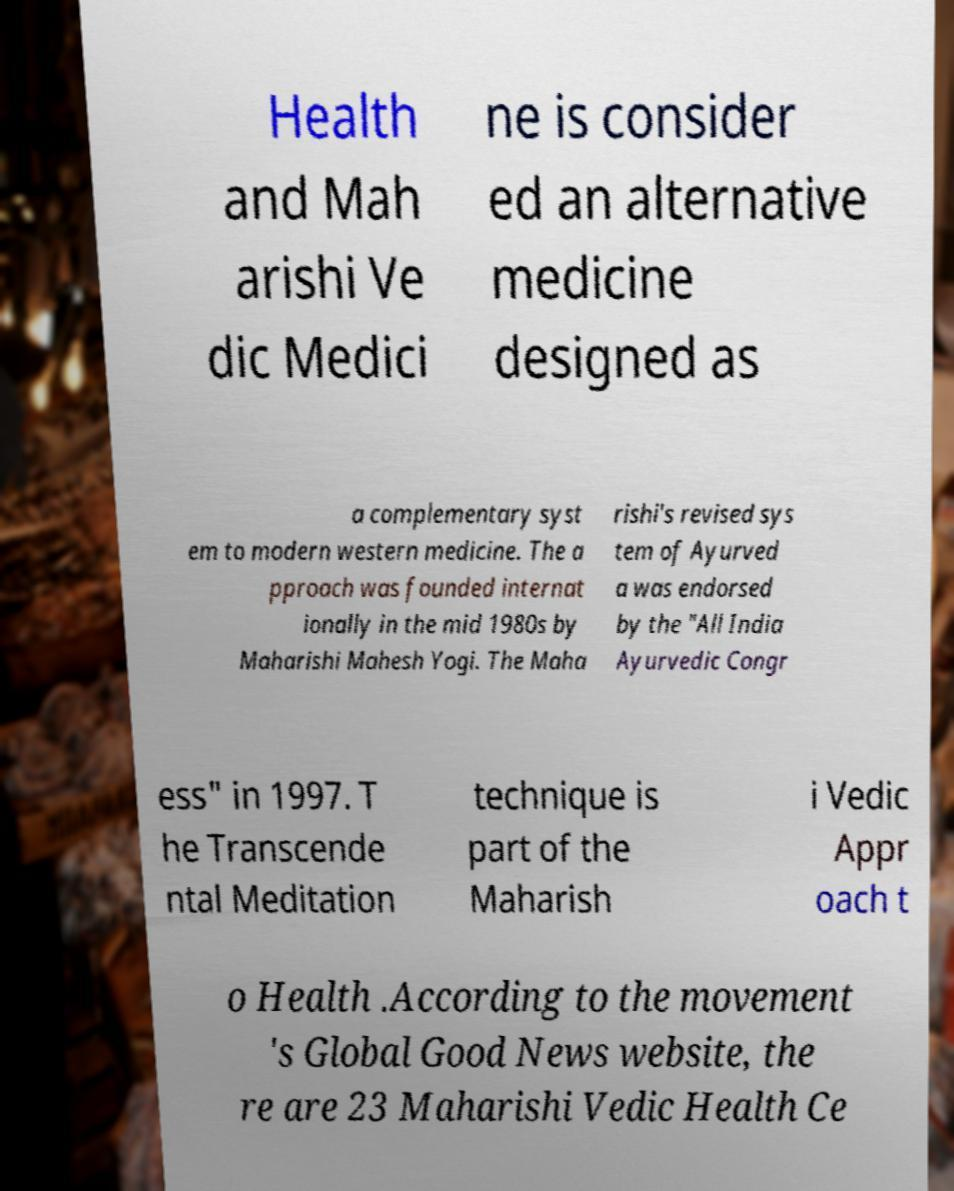Can you accurately transcribe the text from the provided image for me? Health and Mah arishi Ve dic Medici ne is consider ed an alternative medicine designed as a complementary syst em to modern western medicine. The a pproach was founded internat ionally in the mid 1980s by Maharishi Mahesh Yogi. The Maha rishi's revised sys tem of Ayurved a was endorsed by the "All India Ayurvedic Congr ess" in 1997. T he Transcende ntal Meditation technique is part of the Maharish i Vedic Appr oach t o Health .According to the movement 's Global Good News website, the re are 23 Maharishi Vedic Health Ce 